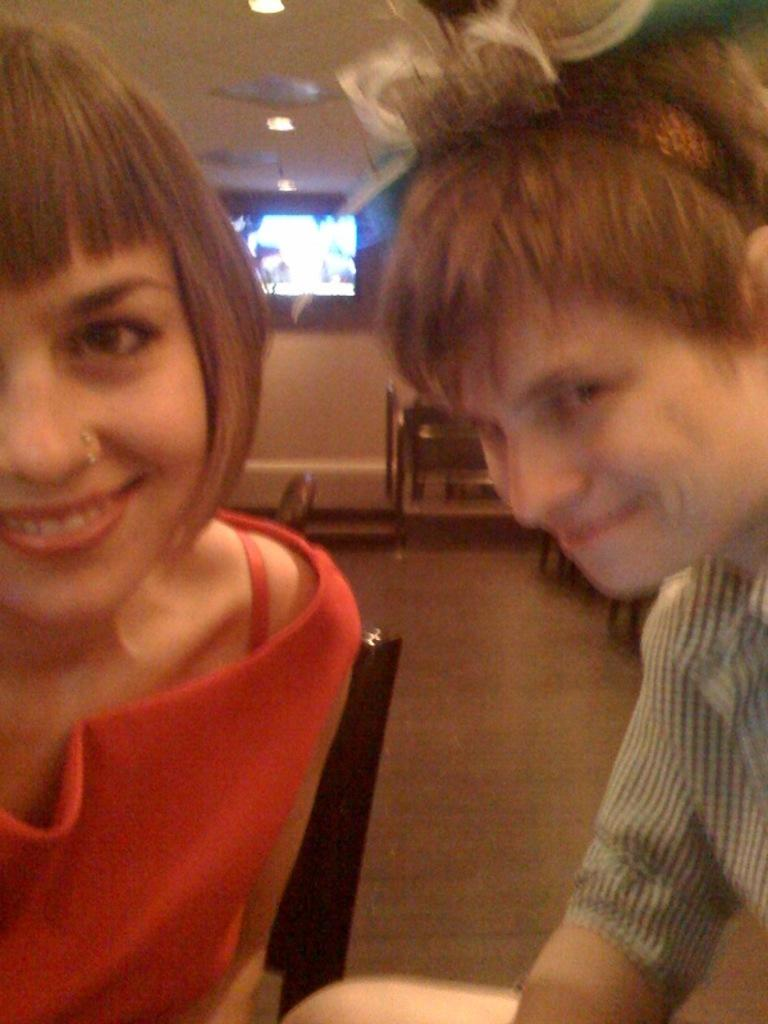What is located in the foreground of the picture? There is a chair, a woman, and a man in the foreground of the picture. Can you describe the objects in the background of the picture? There is a television, lights, and other objects in the background of the picture. What type of heat can be felt coming from the goose in the image? There is no goose present in the image, so it is not possible to determine what type of heat might be felt. 